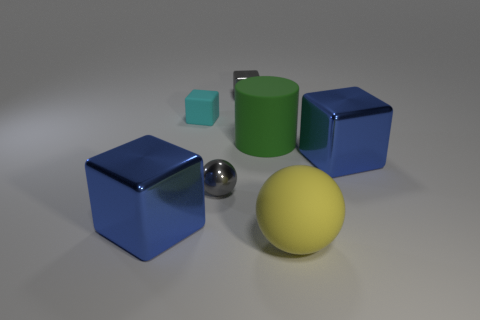Subtract all small shiny cubes. How many cubes are left? 3 Add 1 blue shiny things. How many objects exist? 8 Subtract all blue blocks. How many blocks are left? 2 Subtract all balls. How many objects are left? 5 Add 1 rubber balls. How many rubber balls exist? 2 Subtract 1 gray balls. How many objects are left? 6 Subtract 2 cubes. How many cubes are left? 2 Subtract all blue cubes. Subtract all green cylinders. How many cubes are left? 2 Subtract all gray cylinders. How many gray spheres are left? 1 Subtract all yellow rubber spheres. Subtract all tiny gray blocks. How many objects are left? 5 